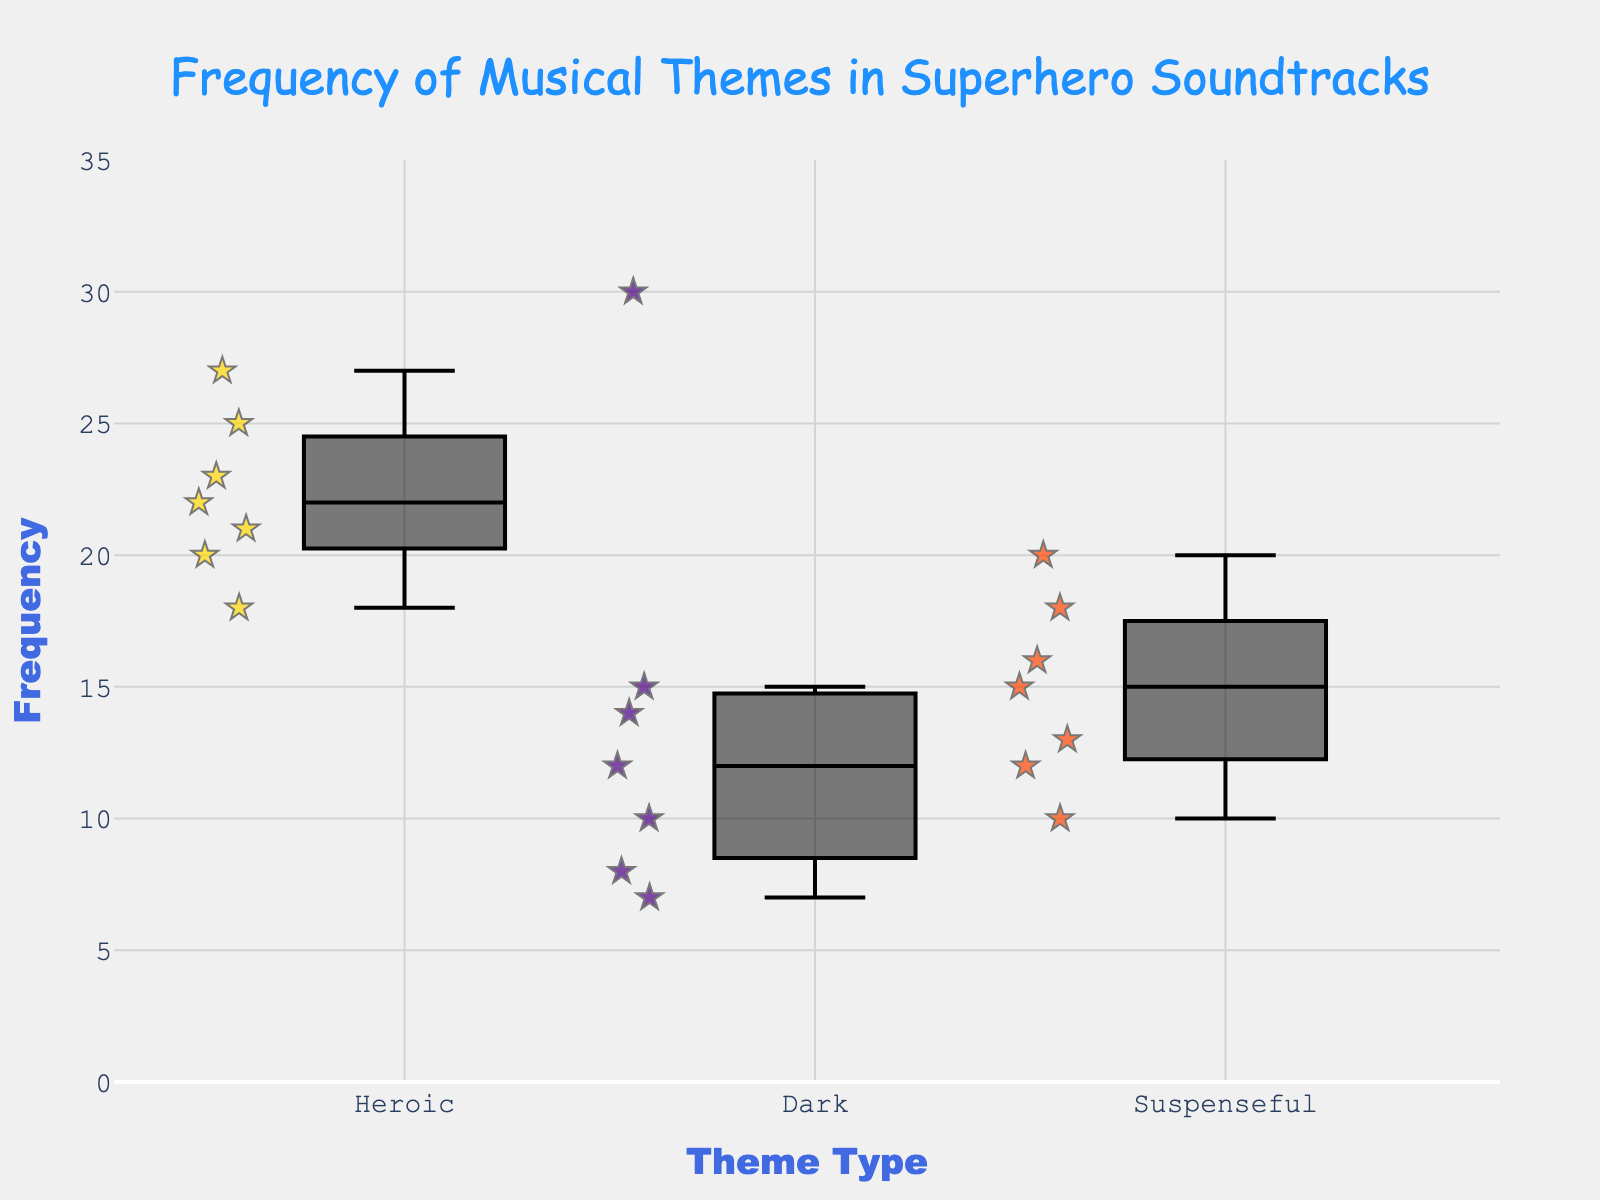What is the title of the figure? The title can be found at the top center of the figure.
Answer: Frequency of Musical Themes in Superhero Soundtracks How many theme types are represented in the figure? The theme types are listed on the x-axis labels; counting these labels reveals the number of types.
Answer: 3 Which theme type has the highest median frequency? Observe the central line (median) within each box; the box with the highest central line represents the highest median.
Answer: Heroic Which theme type has the lowest maximum frequency? The maximum frequency is the upper whisker of the box plot; the box with the lowest upper whisker represents the lowest maximum frequency.
Answer: Suspenseful What's the range of frequencies for the Dark theme? Find the minimum and maximum values of the whiskers (bottom and top) of the Dark box plot and subtract the minimum from the maximum.
Answer: 7 to 30 Comparing Heroic and Dark themes, which has the larger interquartile range (IQR)? The IQR is the difference between the 75th and 25th percentiles, represented by the height of the box. Measure and compare the height of the boxes for Heroic and Dark themes.
Answer: Dark Which superhero film has the highest frequency for the Heroic theme? Identify the data points (stars) within the Heroic box plot and locate the highest one, then check its label.
Answer: Guardians of the Galaxy What is the median frequency of the Suspenseful theme? The median is represented by the central line inside the box plot for the Suspenseful theme.
Answer: 15 Among the theme types, which one shows the greatest variability in frequency? Variability is represented by the length of the box and whiskers; the longest combination indicates the greatest variability.
Answer: Dark What is the color of the Suspenseful theme in the box plot? Each theme has a distinct color. Suspenseful's color can be identified by its box color in the legend or the plot.
Answer: Orange 